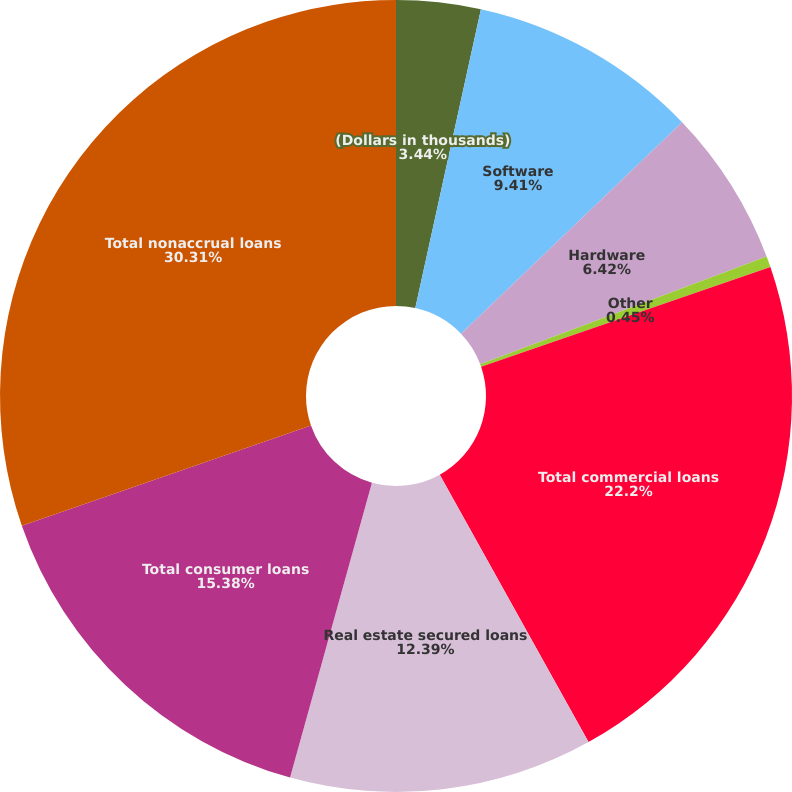<chart> <loc_0><loc_0><loc_500><loc_500><pie_chart><fcel>(Dollars in thousands)<fcel>Software<fcel>Hardware<fcel>Other<fcel>Total commercial loans<fcel>Real estate secured loans<fcel>Total consumer loans<fcel>Total nonaccrual loans<nl><fcel>3.44%<fcel>9.41%<fcel>6.42%<fcel>0.45%<fcel>22.2%<fcel>12.39%<fcel>15.38%<fcel>30.31%<nl></chart> 